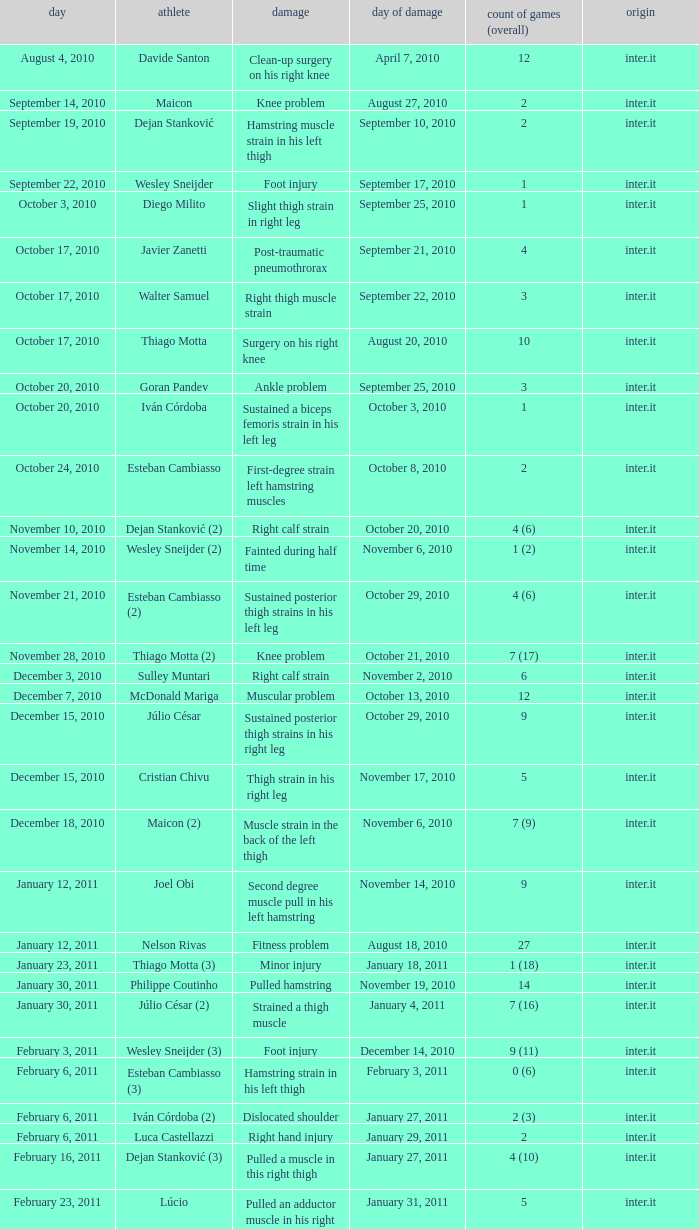Could you parse the entire table? {'header': ['day', 'athlete', 'damage', 'day of damage', 'count of games (overall)', 'origin'], 'rows': [['August 4, 2010', 'Davide Santon', 'Clean-up surgery on his right knee', 'April 7, 2010', '12', 'inter.it'], ['September 14, 2010', 'Maicon', 'Knee problem', 'August 27, 2010', '2', 'inter.it'], ['September 19, 2010', 'Dejan Stanković', 'Hamstring muscle strain in his left thigh', 'September 10, 2010', '2', 'inter.it'], ['September 22, 2010', 'Wesley Sneijder', 'Foot injury', 'September 17, 2010', '1', 'inter.it'], ['October 3, 2010', 'Diego Milito', 'Slight thigh strain in right leg', 'September 25, 2010', '1', 'inter.it'], ['October 17, 2010', 'Javier Zanetti', 'Post-traumatic pneumothrorax', 'September 21, 2010', '4', 'inter.it'], ['October 17, 2010', 'Walter Samuel', 'Right thigh muscle strain', 'September 22, 2010', '3', 'inter.it'], ['October 17, 2010', 'Thiago Motta', 'Surgery on his right knee', 'August 20, 2010', '10', 'inter.it'], ['October 20, 2010', 'Goran Pandev', 'Ankle problem', 'September 25, 2010', '3', 'inter.it'], ['October 20, 2010', 'Iván Córdoba', 'Sustained a biceps femoris strain in his left leg', 'October 3, 2010', '1', 'inter.it'], ['October 24, 2010', 'Esteban Cambiasso', 'First-degree strain left hamstring muscles', 'October 8, 2010', '2', 'inter.it'], ['November 10, 2010', 'Dejan Stanković (2)', 'Right calf strain', 'October 20, 2010', '4 (6)', 'inter.it'], ['November 14, 2010', 'Wesley Sneijder (2)', 'Fainted during half time', 'November 6, 2010', '1 (2)', 'inter.it'], ['November 21, 2010', 'Esteban Cambiasso (2)', 'Sustained posterior thigh strains in his left leg', 'October 29, 2010', '4 (6)', 'inter.it'], ['November 28, 2010', 'Thiago Motta (2)', 'Knee problem', 'October 21, 2010', '7 (17)', 'inter.it'], ['December 3, 2010', 'Sulley Muntari', 'Right calf strain', 'November 2, 2010', '6', 'inter.it'], ['December 7, 2010', 'McDonald Mariga', 'Muscular problem', 'October 13, 2010', '12', 'inter.it'], ['December 15, 2010', 'Júlio César', 'Sustained posterior thigh strains in his right leg', 'October 29, 2010', '9', 'inter.it'], ['December 15, 2010', 'Cristian Chivu', 'Thigh strain in his right leg', 'November 17, 2010', '5', 'inter.it'], ['December 18, 2010', 'Maicon (2)', 'Muscle strain in the back of the left thigh', 'November 6, 2010', '7 (9)', 'inter.it'], ['January 12, 2011', 'Joel Obi', 'Second degree muscle pull in his left hamstring', 'November 14, 2010', '9', 'inter.it'], ['January 12, 2011', 'Nelson Rivas', 'Fitness problem', 'August 18, 2010', '27', 'inter.it'], ['January 23, 2011', 'Thiago Motta (3)', 'Minor injury', 'January 18, 2011', '1 (18)', 'inter.it'], ['January 30, 2011', 'Philippe Coutinho', 'Pulled hamstring', 'November 19, 2010', '14', 'inter.it'], ['January 30, 2011', 'Júlio César (2)', 'Strained a thigh muscle', 'January 4, 2011', '7 (16)', 'inter.it'], ['February 3, 2011', 'Wesley Sneijder (3)', 'Foot injury', 'December 14, 2010', '9 (11)', 'inter.it'], ['February 6, 2011', 'Esteban Cambiasso (3)', 'Hamstring strain in his left thigh', 'February 3, 2011', '0 (6)', 'inter.it'], ['February 6, 2011', 'Iván Córdoba (2)', 'Dislocated shoulder', 'January 27, 2011', '2 (3)', 'inter.it'], ['February 6, 2011', 'Luca Castellazzi', 'Right hand injury', 'January 29, 2011', '2', 'inter.it'], ['February 16, 2011', 'Dejan Stanković (3)', 'Pulled a muscle in this right thigh', 'January 27, 2011', '4 (10)', 'inter.it'], ['February 23, 2011', 'Lúcio', 'Pulled an adductor muscle in his right thigh', 'January 31, 2011', '5', 'inter.it']]} What is the date of injury when the injury is sustained posterior thigh strains in his left leg? October 29, 2010. 